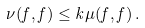<formula> <loc_0><loc_0><loc_500><loc_500>\nu ( f , f ) \leq k \mu ( f , f ) \, .</formula> 